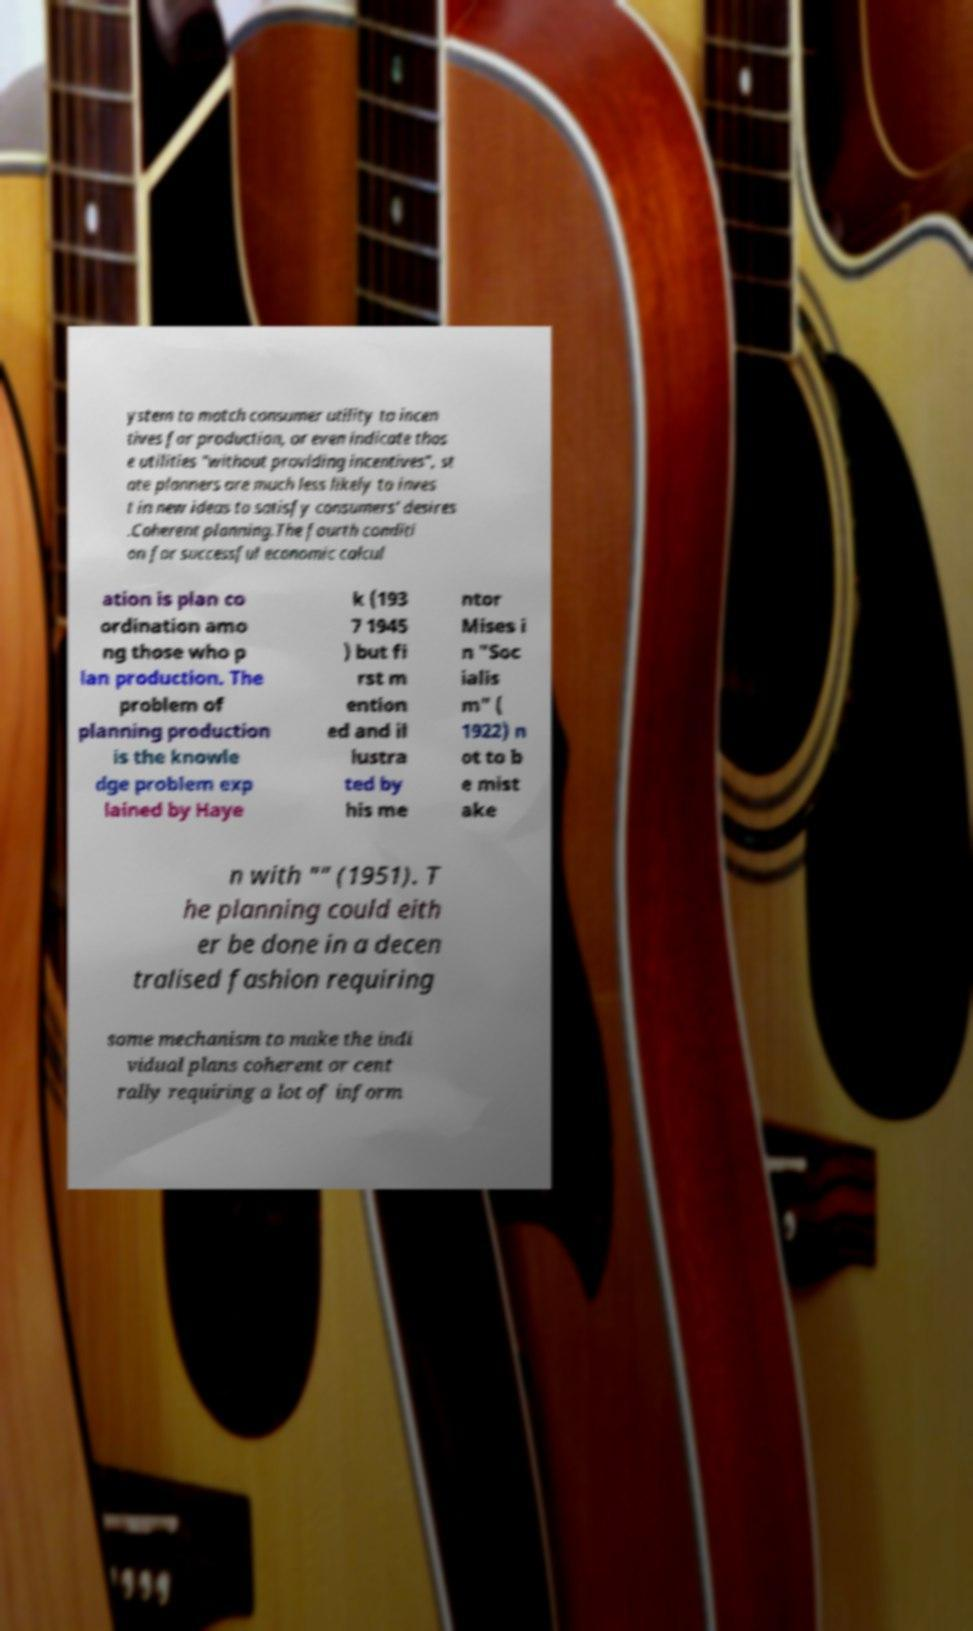Could you assist in decoding the text presented in this image and type it out clearly? ystem to match consumer utility to incen tives for production, or even indicate thos e utilities "without providing incentives", st ate planners are much less likely to inves t in new ideas to satisfy consumers' desires .Coherent planning.The fourth conditi on for successful economic calcul ation is plan co ordination amo ng those who p lan production. The problem of planning production is the knowle dge problem exp lained by Haye k (193 7 1945 ) but fi rst m ention ed and il lustra ted by his me ntor Mises i n "Soc ialis m" ( 1922) n ot to b e mist ake n with "" (1951). T he planning could eith er be done in a decen tralised fashion requiring some mechanism to make the indi vidual plans coherent or cent rally requiring a lot of inform 